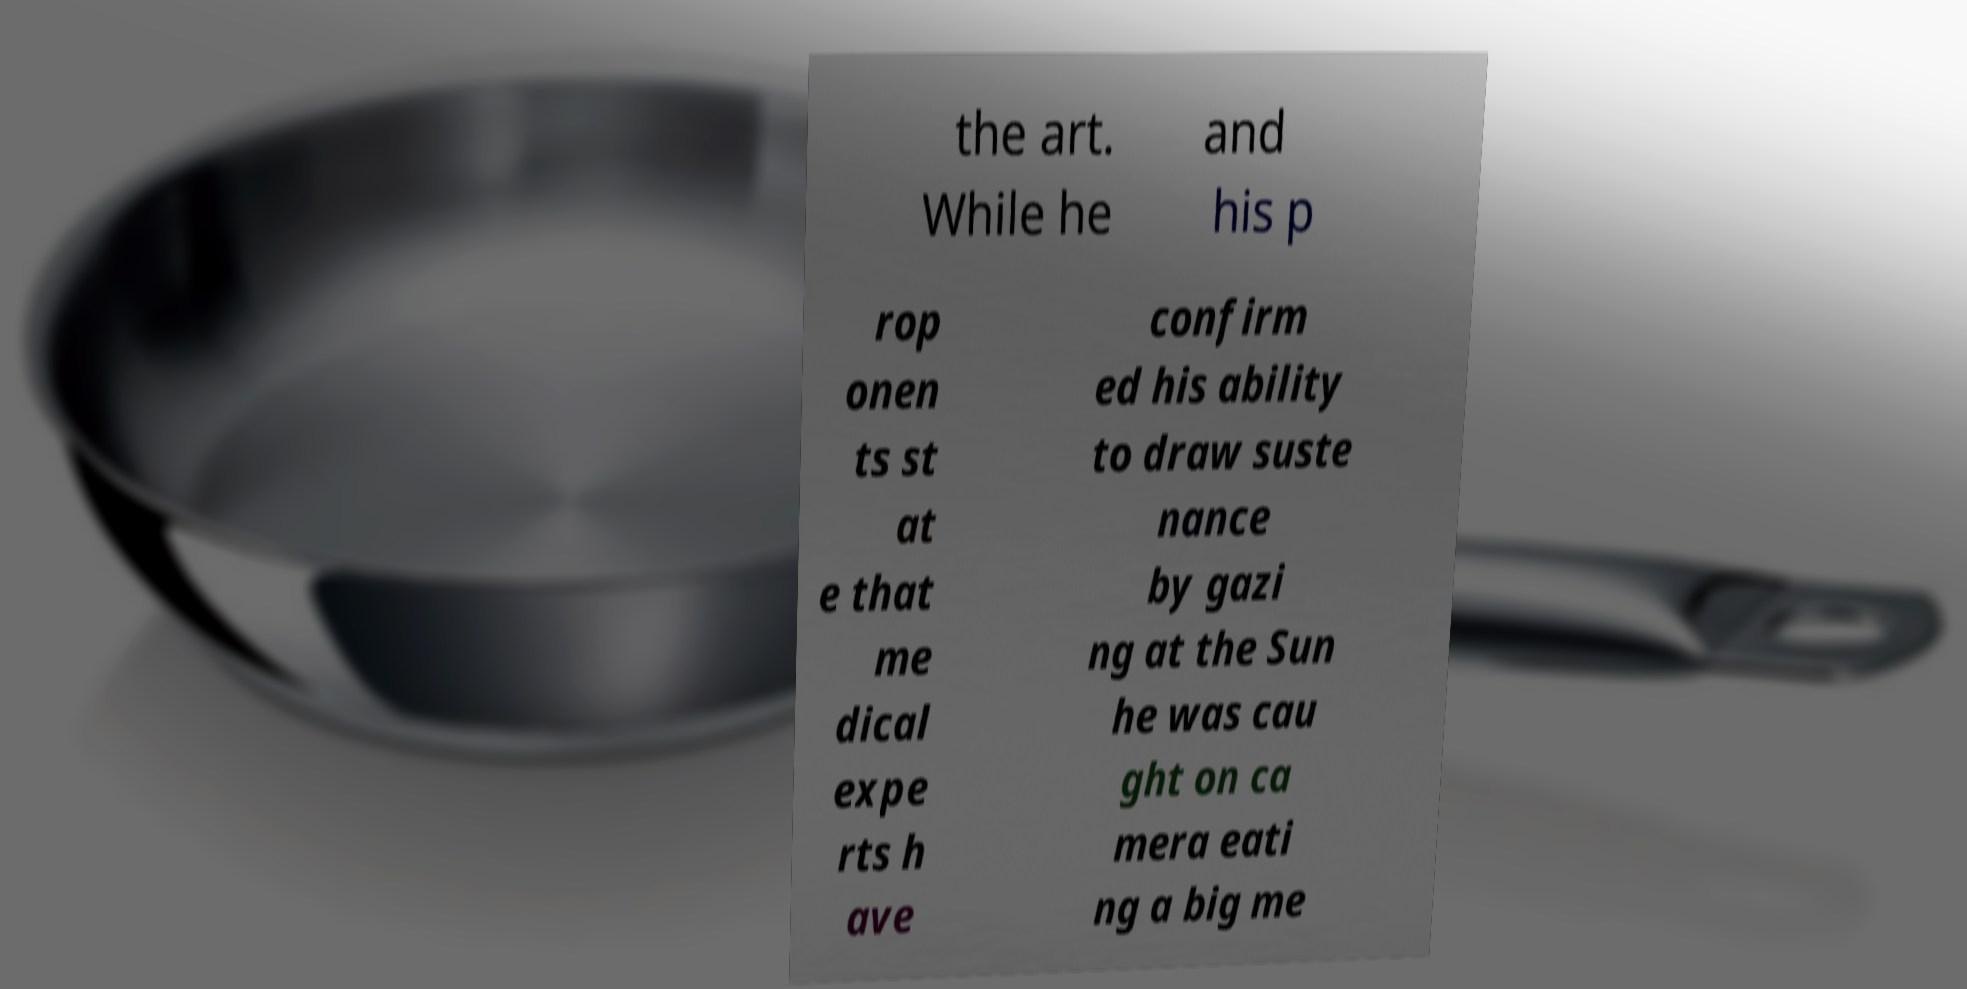There's text embedded in this image that I need extracted. Can you transcribe it verbatim? the art. While he and his p rop onen ts st at e that me dical expe rts h ave confirm ed his ability to draw suste nance by gazi ng at the Sun he was cau ght on ca mera eati ng a big me 